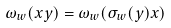<formula> <loc_0><loc_0><loc_500><loc_500>\omega _ { w } ( x y ) = \omega _ { w } ( \sigma _ { w } ( y ) x )</formula> 